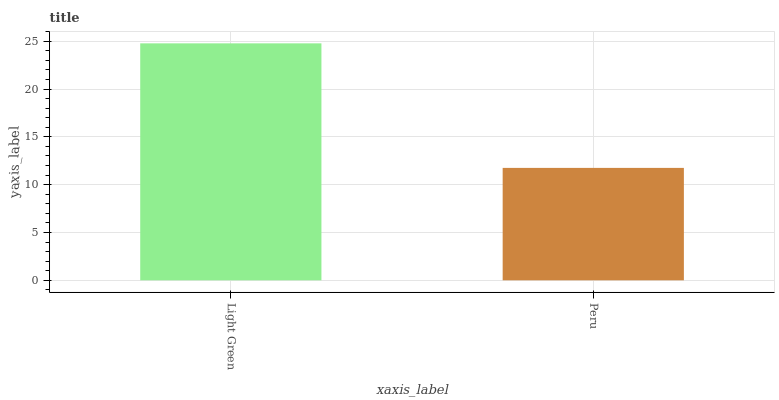Is Peru the minimum?
Answer yes or no. Yes. Is Light Green the maximum?
Answer yes or no. Yes. Is Peru the maximum?
Answer yes or no. No. Is Light Green greater than Peru?
Answer yes or no. Yes. Is Peru less than Light Green?
Answer yes or no. Yes. Is Peru greater than Light Green?
Answer yes or no. No. Is Light Green less than Peru?
Answer yes or no. No. Is Light Green the high median?
Answer yes or no. Yes. Is Peru the low median?
Answer yes or no. Yes. Is Peru the high median?
Answer yes or no. No. Is Light Green the low median?
Answer yes or no. No. 